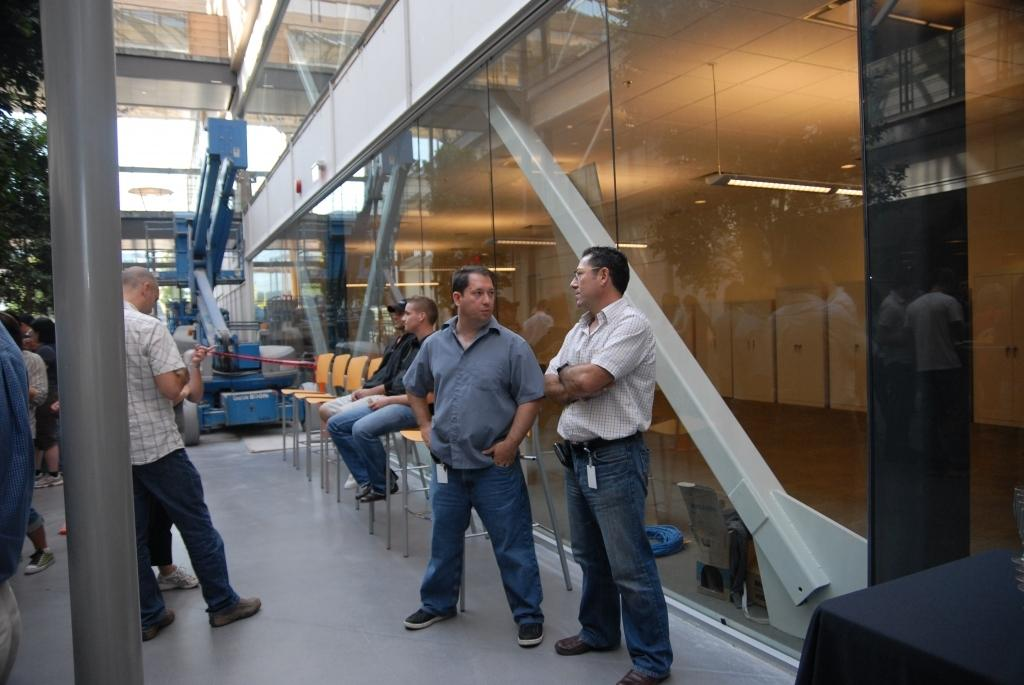What is happening in the image? There are people standing in the image. Can you describe the seating arrangement in the image? There are two men sitting on chairs in the image. What can be seen in the distance in the image? There is a building visible in the background of the image. What type of vase is being used by the people in the image? There is no vase present in the image. How does the hair of the people in the image look? The provided facts do not mention the hair of the people in the image, so we cannot answer this question. 